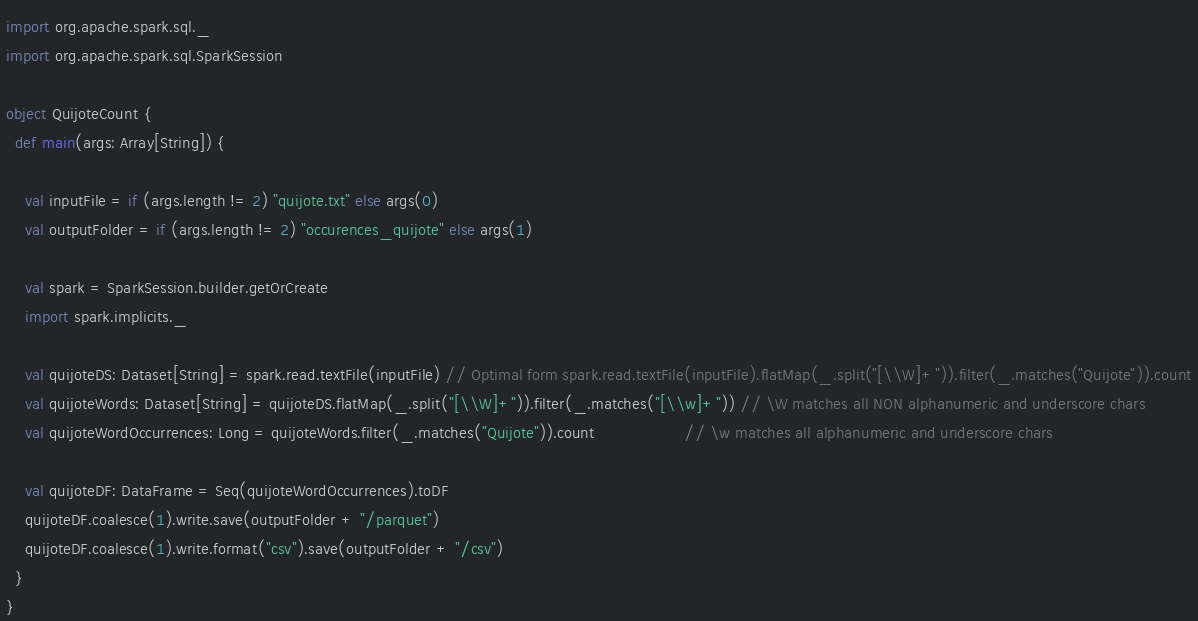Convert code to text. <code><loc_0><loc_0><loc_500><loc_500><_Scala_>
import org.apache.spark.sql._
import org.apache.spark.sql.SparkSession

object QuijoteCount {
  def main(args: Array[String]) {

    val inputFile = if (args.length != 2) "quijote.txt" else args(0)
    val outputFolder = if (args.length != 2) "occurences_quijote" else args(1)

    val spark = SparkSession.builder.getOrCreate
    import spark.implicits._

    val quijoteDS: Dataset[String] = spark.read.textFile(inputFile) // Optimal form spark.read.textFile(inputFile).flatMap(_.split("[\\W]+")).filter(_.matches("Quijote")).count
    val quijoteWords: Dataset[String] = quijoteDS.flatMap(_.split("[\\W]+")).filter(_.matches("[\\w]+")) // \W matches all NON alphanumeric and underscore chars
    val quijoteWordOccurrences: Long = quijoteWords.filter(_.matches("Quijote")).count                   // \w matches all alphanumeric and underscore chars

    val quijoteDF: DataFrame = Seq(quijoteWordOccurrences).toDF 
    quijoteDF.coalesce(1).write.save(outputFolder + "/parquet")
    quijoteDF.coalesce(1).write.format("csv").save(outputFolder + "/csv")
  }
}
</code> 